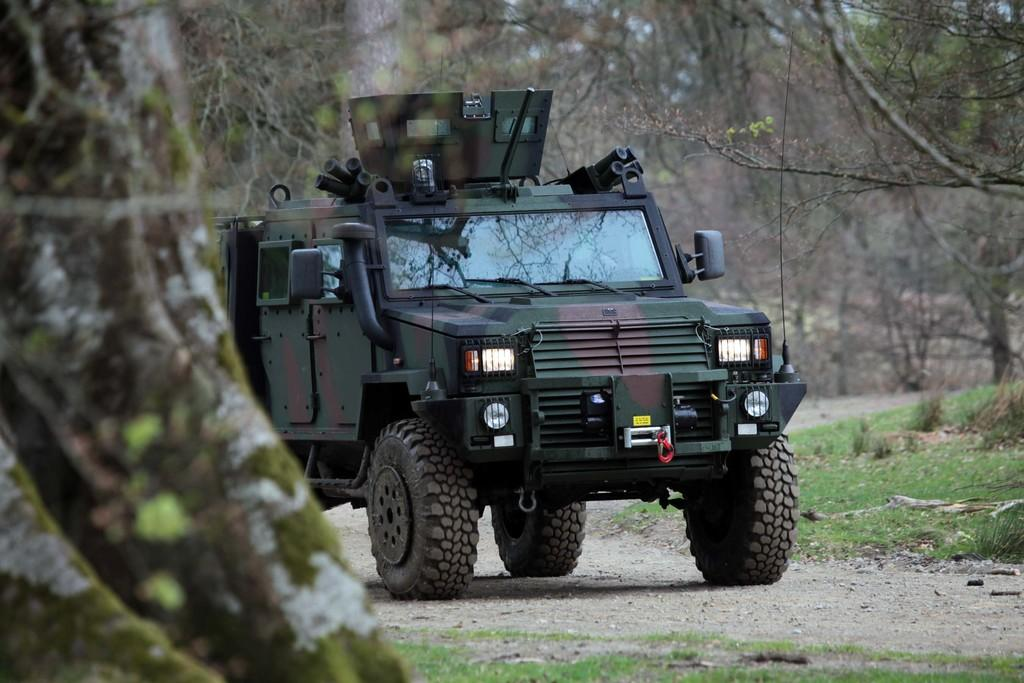What is located on the ground in the image? There is a vehicle on the ground in the image. What can be seen on the left side of the image? There is a tree trunk on the left side of the image. What type of vegetation is visible in the background of the image? There is grass visible in the background of the image. What else can be seen in the background of the image? There are trees in the background of the image. What type of net is being used to catch the iron in the image? There is no net or iron present in the image. 